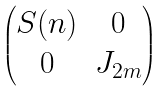Convert formula to latex. <formula><loc_0><loc_0><loc_500><loc_500>\begin{pmatrix} S ( n ) & 0 \\ 0 & J _ { 2 m } \end{pmatrix}</formula> 